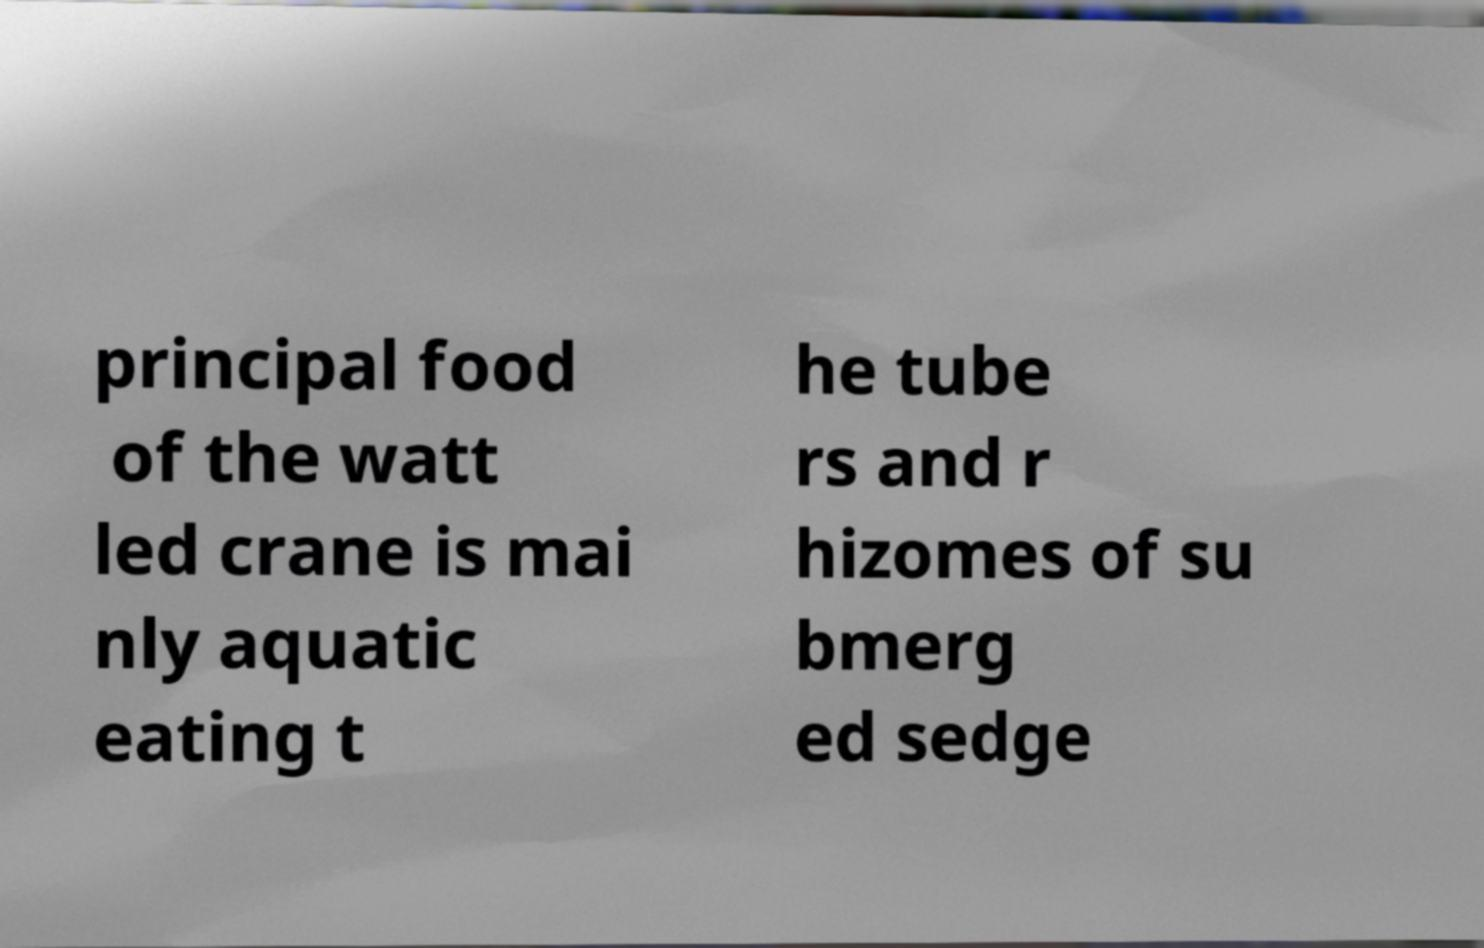I need the written content from this picture converted into text. Can you do that? principal food of the watt led crane is mai nly aquatic eating t he tube rs and r hizomes of su bmerg ed sedge 